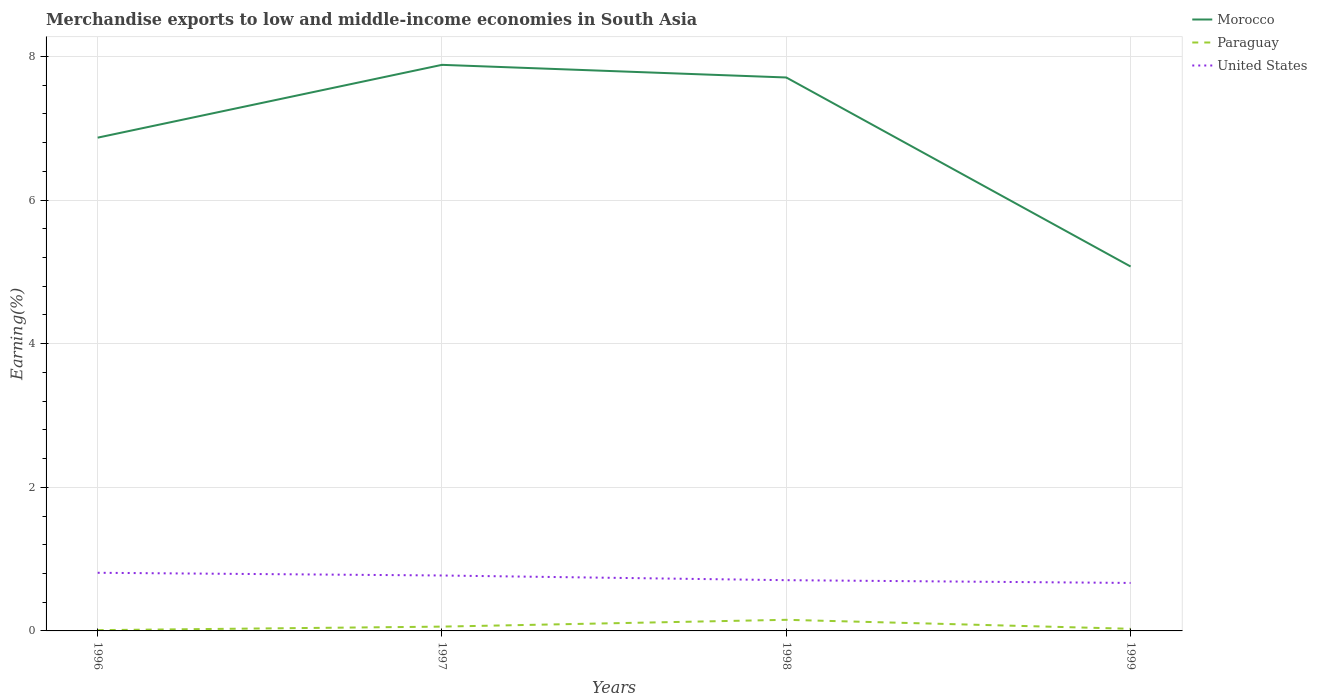Across all years, what is the maximum percentage of amount earned from merchandise exports in Paraguay?
Offer a very short reply. 0.01. What is the total percentage of amount earned from merchandise exports in Morocco in the graph?
Offer a very short reply. -1.01. What is the difference between the highest and the second highest percentage of amount earned from merchandise exports in Paraguay?
Give a very brief answer. 0.14. Is the percentage of amount earned from merchandise exports in Paraguay strictly greater than the percentage of amount earned from merchandise exports in United States over the years?
Offer a terse response. Yes. How many lines are there?
Ensure brevity in your answer.  3. Are the values on the major ticks of Y-axis written in scientific E-notation?
Your answer should be compact. No. Does the graph contain any zero values?
Provide a succinct answer. No. Does the graph contain grids?
Your answer should be compact. Yes. How many legend labels are there?
Provide a short and direct response. 3. What is the title of the graph?
Keep it short and to the point. Merchandise exports to low and middle-income economies in South Asia. What is the label or title of the Y-axis?
Ensure brevity in your answer.  Earning(%). What is the Earning(%) of Morocco in 1996?
Your response must be concise. 6.87. What is the Earning(%) of Paraguay in 1996?
Keep it short and to the point. 0.01. What is the Earning(%) of United States in 1996?
Make the answer very short. 0.81. What is the Earning(%) in Morocco in 1997?
Provide a short and direct response. 7.88. What is the Earning(%) of Paraguay in 1997?
Provide a short and direct response. 0.06. What is the Earning(%) of United States in 1997?
Offer a very short reply. 0.77. What is the Earning(%) of Morocco in 1998?
Make the answer very short. 7.71. What is the Earning(%) in Paraguay in 1998?
Your answer should be compact. 0.15. What is the Earning(%) of United States in 1998?
Provide a succinct answer. 0.71. What is the Earning(%) in Morocco in 1999?
Give a very brief answer. 5.07. What is the Earning(%) of Paraguay in 1999?
Your answer should be very brief. 0.03. What is the Earning(%) of United States in 1999?
Give a very brief answer. 0.67. Across all years, what is the maximum Earning(%) of Morocco?
Your answer should be very brief. 7.88. Across all years, what is the maximum Earning(%) of Paraguay?
Give a very brief answer. 0.15. Across all years, what is the maximum Earning(%) of United States?
Provide a succinct answer. 0.81. Across all years, what is the minimum Earning(%) of Morocco?
Your response must be concise. 5.07. Across all years, what is the minimum Earning(%) in Paraguay?
Make the answer very short. 0.01. Across all years, what is the minimum Earning(%) of United States?
Provide a short and direct response. 0.67. What is the total Earning(%) in Morocco in the graph?
Provide a succinct answer. 27.53. What is the total Earning(%) of Paraguay in the graph?
Your answer should be very brief. 0.26. What is the total Earning(%) in United States in the graph?
Your answer should be very brief. 2.96. What is the difference between the Earning(%) in Morocco in 1996 and that in 1997?
Offer a terse response. -1.01. What is the difference between the Earning(%) of Paraguay in 1996 and that in 1997?
Make the answer very short. -0.05. What is the difference between the Earning(%) of United States in 1996 and that in 1997?
Keep it short and to the point. 0.04. What is the difference between the Earning(%) in Morocco in 1996 and that in 1998?
Provide a short and direct response. -0.84. What is the difference between the Earning(%) of Paraguay in 1996 and that in 1998?
Make the answer very short. -0.14. What is the difference between the Earning(%) of United States in 1996 and that in 1998?
Provide a short and direct response. 0.1. What is the difference between the Earning(%) of Morocco in 1996 and that in 1999?
Your response must be concise. 1.79. What is the difference between the Earning(%) of Paraguay in 1996 and that in 1999?
Give a very brief answer. -0.02. What is the difference between the Earning(%) of United States in 1996 and that in 1999?
Your response must be concise. 0.14. What is the difference between the Earning(%) of Morocco in 1997 and that in 1998?
Your answer should be very brief. 0.18. What is the difference between the Earning(%) in Paraguay in 1997 and that in 1998?
Make the answer very short. -0.09. What is the difference between the Earning(%) in United States in 1997 and that in 1998?
Provide a succinct answer. 0.07. What is the difference between the Earning(%) in Morocco in 1997 and that in 1999?
Make the answer very short. 2.81. What is the difference between the Earning(%) in Paraguay in 1997 and that in 1999?
Keep it short and to the point. 0.03. What is the difference between the Earning(%) in United States in 1997 and that in 1999?
Provide a succinct answer. 0.1. What is the difference between the Earning(%) in Morocco in 1998 and that in 1999?
Your answer should be compact. 2.63. What is the difference between the Earning(%) in Paraguay in 1998 and that in 1999?
Give a very brief answer. 0.13. What is the difference between the Earning(%) of United States in 1998 and that in 1999?
Ensure brevity in your answer.  0.04. What is the difference between the Earning(%) in Morocco in 1996 and the Earning(%) in Paraguay in 1997?
Your answer should be very brief. 6.81. What is the difference between the Earning(%) of Morocco in 1996 and the Earning(%) of United States in 1997?
Provide a succinct answer. 6.1. What is the difference between the Earning(%) in Paraguay in 1996 and the Earning(%) in United States in 1997?
Your answer should be very brief. -0.76. What is the difference between the Earning(%) in Morocco in 1996 and the Earning(%) in Paraguay in 1998?
Your response must be concise. 6.71. What is the difference between the Earning(%) of Morocco in 1996 and the Earning(%) of United States in 1998?
Ensure brevity in your answer.  6.16. What is the difference between the Earning(%) of Paraguay in 1996 and the Earning(%) of United States in 1998?
Your answer should be compact. -0.7. What is the difference between the Earning(%) of Morocco in 1996 and the Earning(%) of Paraguay in 1999?
Your answer should be very brief. 6.84. What is the difference between the Earning(%) of Morocco in 1996 and the Earning(%) of United States in 1999?
Provide a short and direct response. 6.2. What is the difference between the Earning(%) in Paraguay in 1996 and the Earning(%) in United States in 1999?
Offer a very short reply. -0.66. What is the difference between the Earning(%) of Morocco in 1997 and the Earning(%) of Paraguay in 1998?
Your response must be concise. 7.73. What is the difference between the Earning(%) of Morocco in 1997 and the Earning(%) of United States in 1998?
Offer a very short reply. 7.18. What is the difference between the Earning(%) in Paraguay in 1997 and the Earning(%) in United States in 1998?
Your answer should be compact. -0.65. What is the difference between the Earning(%) in Morocco in 1997 and the Earning(%) in Paraguay in 1999?
Give a very brief answer. 7.85. What is the difference between the Earning(%) of Morocco in 1997 and the Earning(%) of United States in 1999?
Your response must be concise. 7.21. What is the difference between the Earning(%) in Paraguay in 1997 and the Earning(%) in United States in 1999?
Ensure brevity in your answer.  -0.61. What is the difference between the Earning(%) of Morocco in 1998 and the Earning(%) of Paraguay in 1999?
Your response must be concise. 7.68. What is the difference between the Earning(%) of Morocco in 1998 and the Earning(%) of United States in 1999?
Your answer should be very brief. 7.04. What is the difference between the Earning(%) in Paraguay in 1998 and the Earning(%) in United States in 1999?
Keep it short and to the point. -0.51. What is the average Earning(%) in Morocco per year?
Offer a terse response. 6.88. What is the average Earning(%) in Paraguay per year?
Offer a terse response. 0.06. What is the average Earning(%) of United States per year?
Provide a short and direct response. 0.74. In the year 1996, what is the difference between the Earning(%) of Morocco and Earning(%) of Paraguay?
Provide a short and direct response. 6.86. In the year 1996, what is the difference between the Earning(%) of Morocco and Earning(%) of United States?
Make the answer very short. 6.06. In the year 1996, what is the difference between the Earning(%) of Paraguay and Earning(%) of United States?
Keep it short and to the point. -0.8. In the year 1997, what is the difference between the Earning(%) in Morocco and Earning(%) in Paraguay?
Keep it short and to the point. 7.82. In the year 1997, what is the difference between the Earning(%) in Morocco and Earning(%) in United States?
Give a very brief answer. 7.11. In the year 1997, what is the difference between the Earning(%) of Paraguay and Earning(%) of United States?
Give a very brief answer. -0.71. In the year 1998, what is the difference between the Earning(%) of Morocco and Earning(%) of Paraguay?
Offer a very short reply. 7.55. In the year 1998, what is the difference between the Earning(%) in Morocco and Earning(%) in United States?
Give a very brief answer. 7. In the year 1998, what is the difference between the Earning(%) in Paraguay and Earning(%) in United States?
Ensure brevity in your answer.  -0.55. In the year 1999, what is the difference between the Earning(%) of Morocco and Earning(%) of Paraguay?
Your answer should be compact. 5.04. In the year 1999, what is the difference between the Earning(%) in Morocco and Earning(%) in United States?
Offer a very short reply. 4.41. In the year 1999, what is the difference between the Earning(%) of Paraguay and Earning(%) of United States?
Offer a very short reply. -0.64. What is the ratio of the Earning(%) of Morocco in 1996 to that in 1997?
Provide a short and direct response. 0.87. What is the ratio of the Earning(%) of Paraguay in 1996 to that in 1997?
Ensure brevity in your answer.  0.18. What is the ratio of the Earning(%) in United States in 1996 to that in 1997?
Give a very brief answer. 1.05. What is the ratio of the Earning(%) in Morocco in 1996 to that in 1998?
Provide a short and direct response. 0.89. What is the ratio of the Earning(%) of Paraguay in 1996 to that in 1998?
Offer a very short reply. 0.07. What is the ratio of the Earning(%) in United States in 1996 to that in 1998?
Your answer should be very brief. 1.15. What is the ratio of the Earning(%) of Morocco in 1996 to that in 1999?
Your answer should be very brief. 1.35. What is the ratio of the Earning(%) in Paraguay in 1996 to that in 1999?
Offer a very short reply. 0.37. What is the ratio of the Earning(%) of United States in 1996 to that in 1999?
Make the answer very short. 1.21. What is the ratio of the Earning(%) of Morocco in 1997 to that in 1998?
Offer a terse response. 1.02. What is the ratio of the Earning(%) of Paraguay in 1997 to that in 1998?
Provide a short and direct response. 0.39. What is the ratio of the Earning(%) of United States in 1997 to that in 1998?
Your answer should be very brief. 1.09. What is the ratio of the Earning(%) of Morocco in 1997 to that in 1999?
Your response must be concise. 1.55. What is the ratio of the Earning(%) in Paraguay in 1997 to that in 1999?
Your answer should be compact. 2.03. What is the ratio of the Earning(%) in United States in 1997 to that in 1999?
Offer a very short reply. 1.16. What is the ratio of the Earning(%) of Morocco in 1998 to that in 1999?
Offer a terse response. 1.52. What is the ratio of the Earning(%) in Paraguay in 1998 to that in 1999?
Ensure brevity in your answer.  5.23. What is the ratio of the Earning(%) in United States in 1998 to that in 1999?
Ensure brevity in your answer.  1.06. What is the difference between the highest and the second highest Earning(%) of Morocco?
Offer a terse response. 0.18. What is the difference between the highest and the second highest Earning(%) of Paraguay?
Make the answer very short. 0.09. What is the difference between the highest and the second highest Earning(%) in United States?
Keep it short and to the point. 0.04. What is the difference between the highest and the lowest Earning(%) in Morocco?
Keep it short and to the point. 2.81. What is the difference between the highest and the lowest Earning(%) of Paraguay?
Your answer should be very brief. 0.14. What is the difference between the highest and the lowest Earning(%) in United States?
Ensure brevity in your answer.  0.14. 